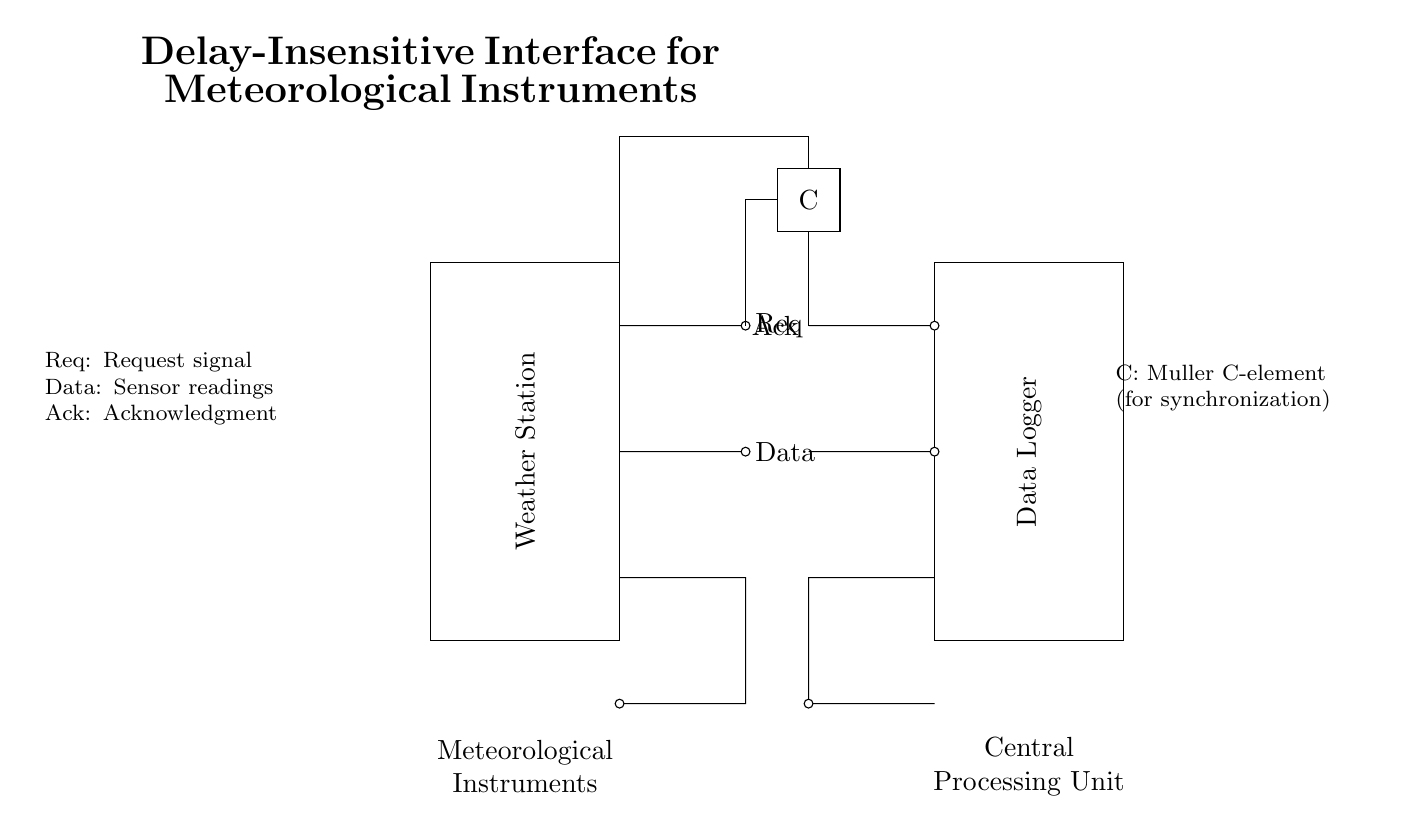What is the purpose of the Muller C-element? The Muller C-element is used for synchronization in asynchronous circuits. It takes two inputs (request and acknowledgment) and produces an output after certain conditions are met, ensuring reliable data transfer between components.
Answer: synchronization What signals are exchanged between the Weather Station and the Data Logger? The circuit shows three main signals exchanged: a request signal (Req), data (Data) from the Weather Station, and an acknowledgment signal (Ack) from the Data Logger. These signals indicate the flow of information and control between the two devices.
Answer: Req, Data, Ack How many instruments are indicated in the circuit? The diagram shows the label "Meteorological Instruments" but does not specify a number of instruments explicitly. Therefore, it is implied that multiple meteorological instruments can be connected within this interface.
Answer: multiple What role does the Weather Station play in this circuit? The Weather Station acts as the sender of both requests for data and the actual sensor readings, providing essential information about weather conditions to the Data Logger for processing.
Answer: sender What connection type is used for the Data line? The Data line is shown as a dashed line, indicating that it is a short electrical connection used to transmit sensor readings from the Weather Station to the Data Logger without interference.
Answer: short What does "Ack" signify in this circuit? "Ack" stands for acknowledgment. It is a signal from the Data Logger confirming receipt of the data from the Weather Station, completing the communication cycle between the two components.
Answer: acknowledgment 